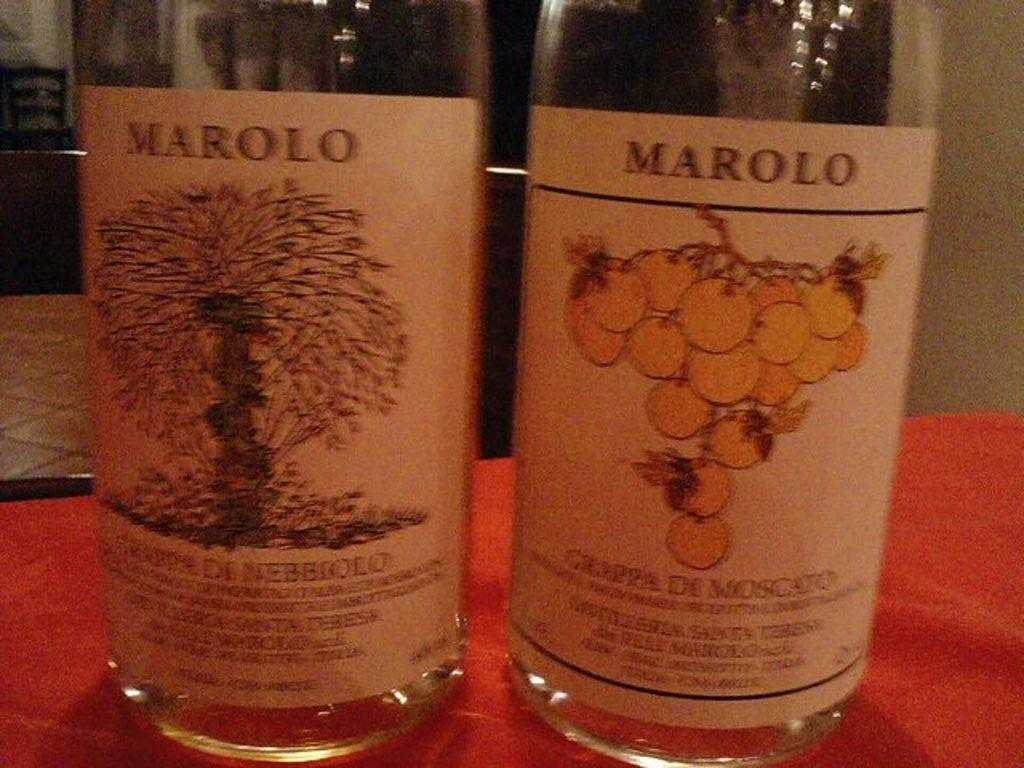<image>
Create a compact narrative representing the image presented. The wine bottles show two different images of wine made by Marolo. 